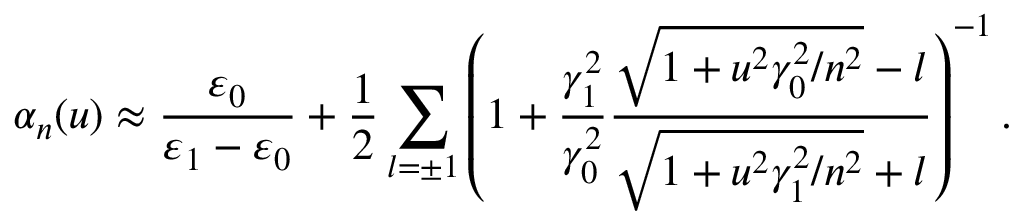<formula> <loc_0><loc_0><loc_500><loc_500>\alpha _ { n } ( u ) \approx \frac { \varepsilon _ { 0 } } { \varepsilon _ { 1 } - \varepsilon _ { 0 } } + \frac { 1 } { 2 } \sum _ { l = \pm 1 } \left ( 1 + \frac { \gamma _ { 1 } ^ { 2 } } { \gamma _ { 0 } ^ { 2 } } \frac { \sqrt { 1 + u ^ { 2 } \gamma _ { 0 } ^ { 2 } / n ^ { 2 } } - l } { \sqrt { 1 + u ^ { 2 } \gamma _ { 1 } ^ { 2 } / n ^ { 2 } } + l } \right ) ^ { - 1 } .</formula> 